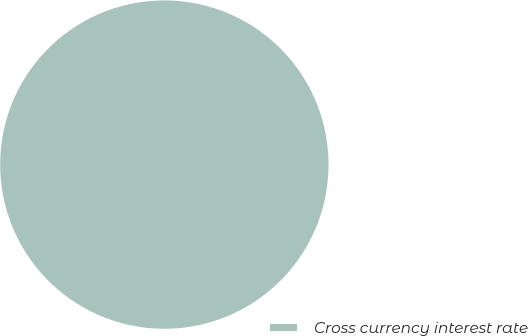Convert chart. <chart><loc_0><loc_0><loc_500><loc_500><pie_chart><fcel>Cross currency interest rate<nl><fcel>100.0%<nl></chart> 